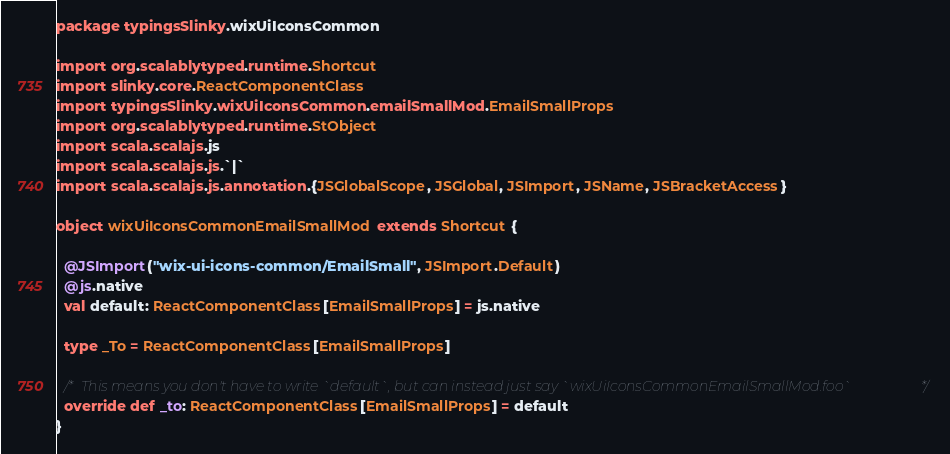<code> <loc_0><loc_0><loc_500><loc_500><_Scala_>package typingsSlinky.wixUiIconsCommon

import org.scalablytyped.runtime.Shortcut
import slinky.core.ReactComponentClass
import typingsSlinky.wixUiIconsCommon.emailSmallMod.EmailSmallProps
import org.scalablytyped.runtime.StObject
import scala.scalajs.js
import scala.scalajs.js.`|`
import scala.scalajs.js.annotation.{JSGlobalScope, JSGlobal, JSImport, JSName, JSBracketAccess}

object wixUiIconsCommonEmailSmallMod extends Shortcut {
  
  @JSImport("wix-ui-icons-common/EmailSmall", JSImport.Default)
  @js.native
  val default: ReactComponentClass[EmailSmallProps] = js.native
  
  type _To = ReactComponentClass[EmailSmallProps]
  
  /* This means you don't have to write `default`, but can instead just say `wixUiIconsCommonEmailSmallMod.foo` */
  override def _to: ReactComponentClass[EmailSmallProps] = default
}
</code> 